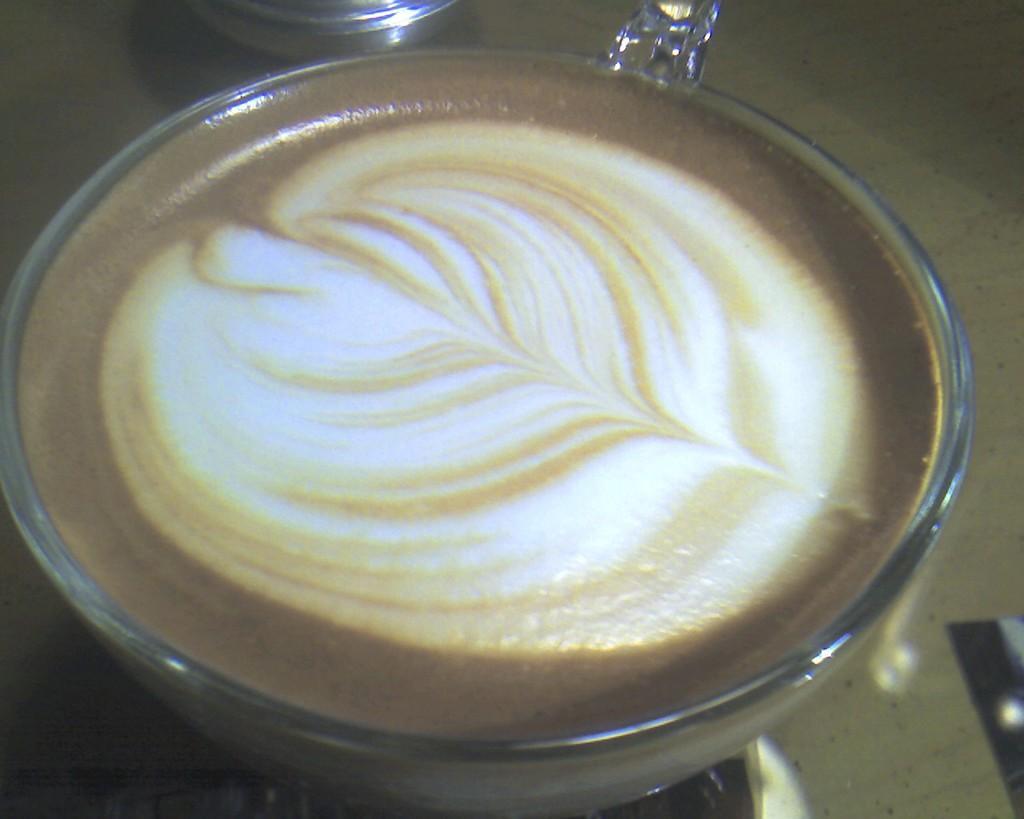In one or two sentences, can you explain what this image depicts? There is a coffee placed in a cup on the table. 